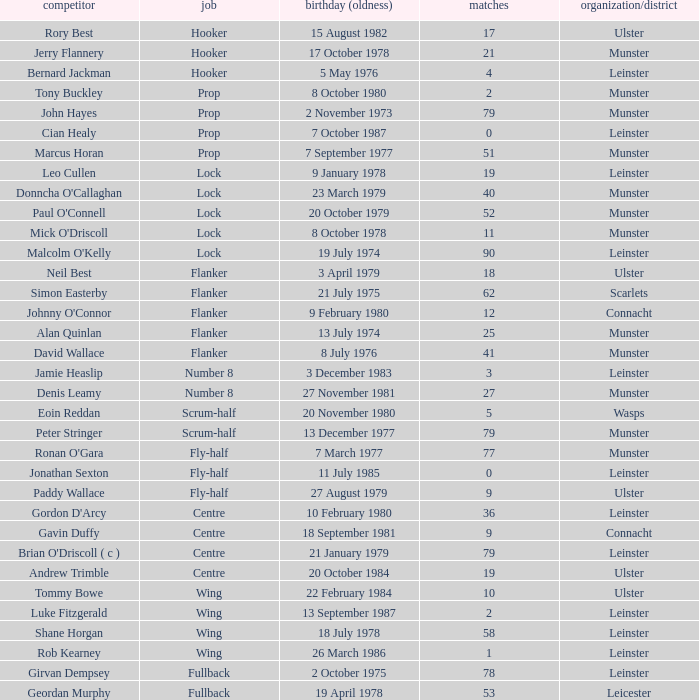Paddy Wallace who plays the position of fly-half has how many Caps? 9.0. 